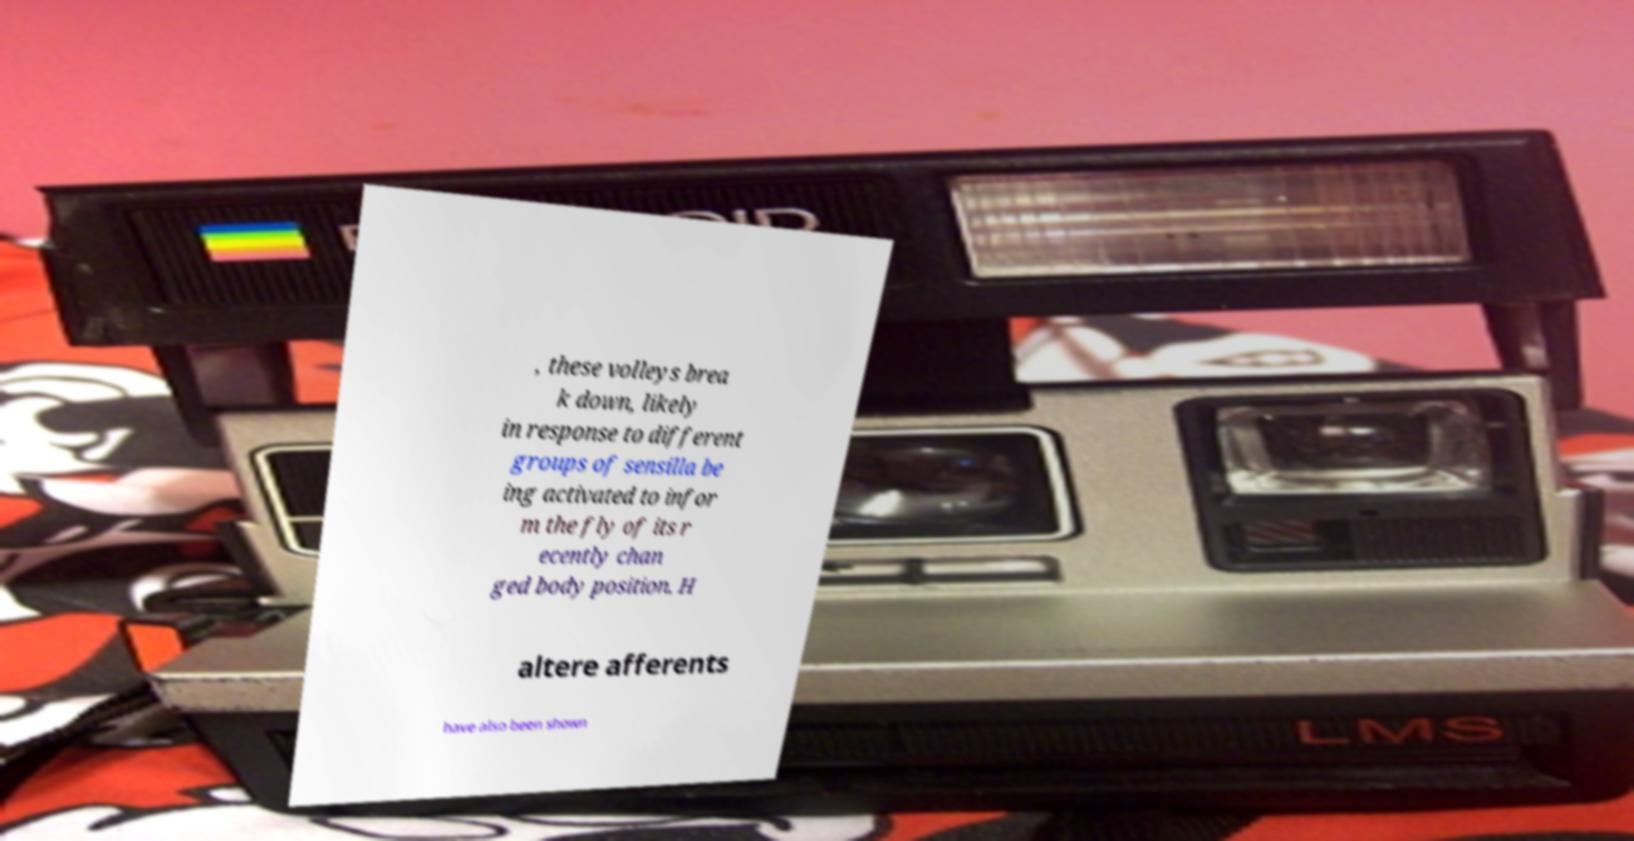For documentation purposes, I need the text within this image transcribed. Could you provide that? , these volleys brea k down, likely in response to different groups of sensilla be ing activated to infor m the fly of its r ecently chan ged body position. H altere afferents have also been shown 